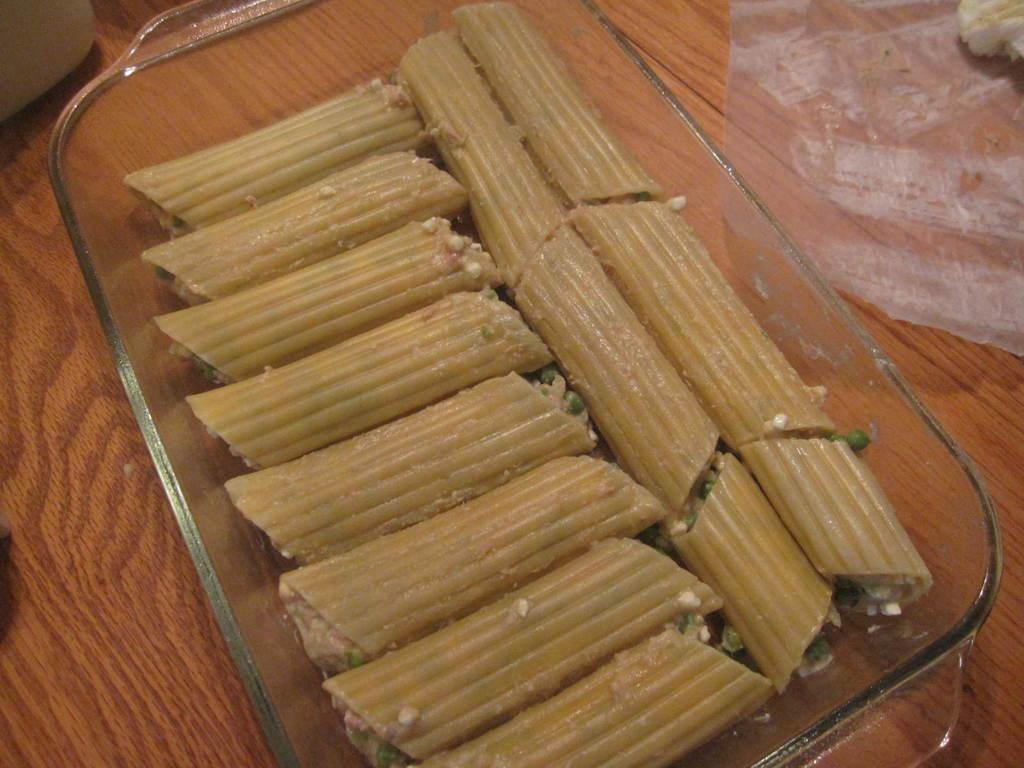Describe this image in one or two sentences. In this image we can see food item in a glass plate, paper and objects on a table. 